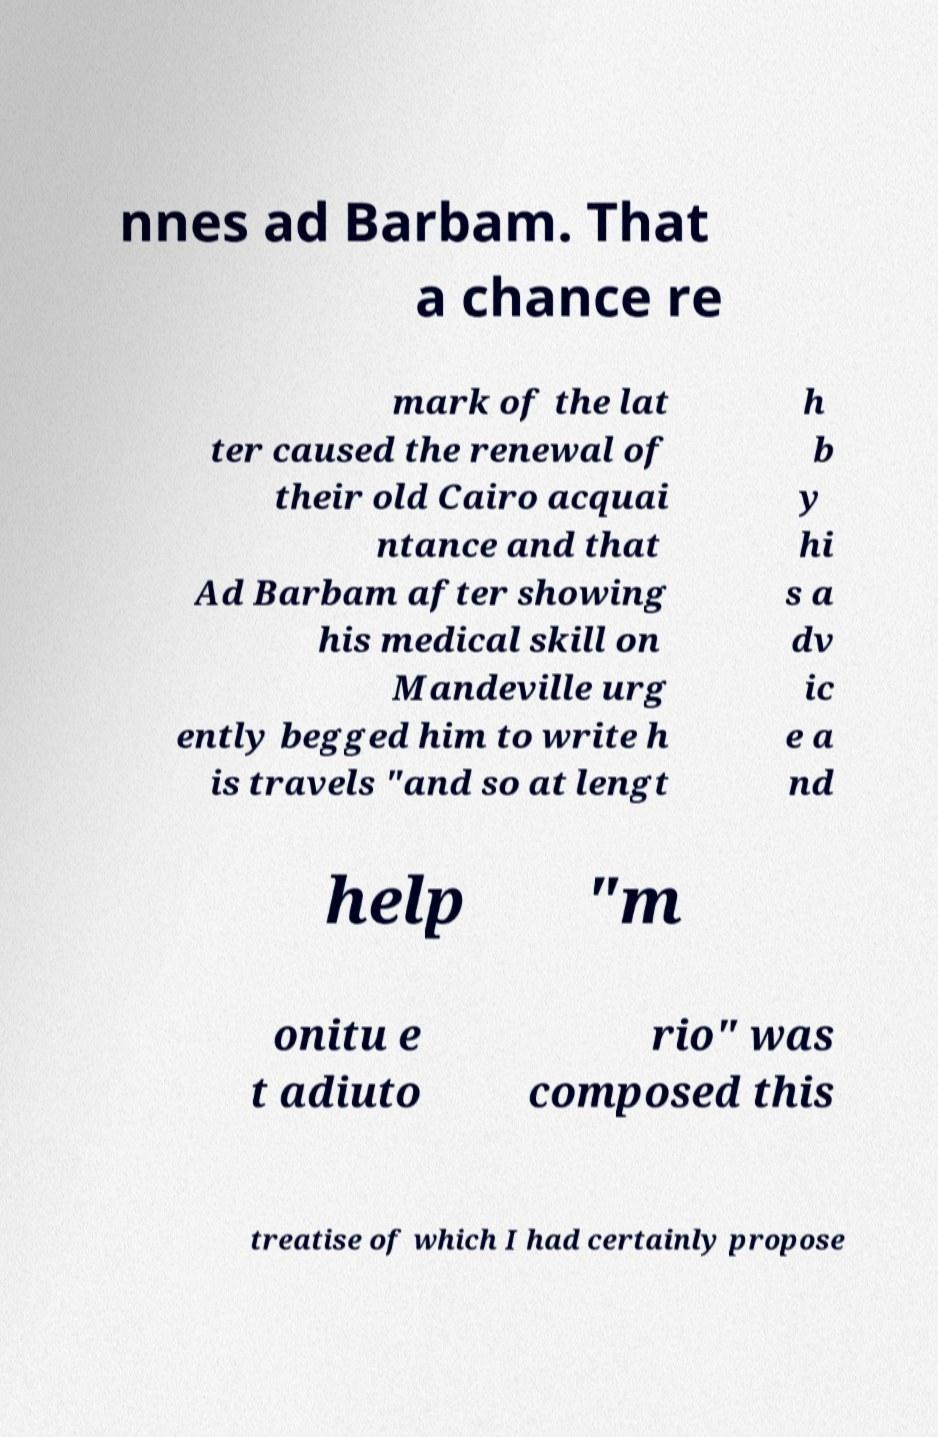Can you read and provide the text displayed in the image?This photo seems to have some interesting text. Can you extract and type it out for me? nnes ad Barbam. That a chance re mark of the lat ter caused the renewal of their old Cairo acquai ntance and that Ad Barbam after showing his medical skill on Mandeville urg ently begged him to write h is travels "and so at lengt h b y hi s a dv ic e a nd help "m onitu e t adiuto rio" was composed this treatise of which I had certainly propose 